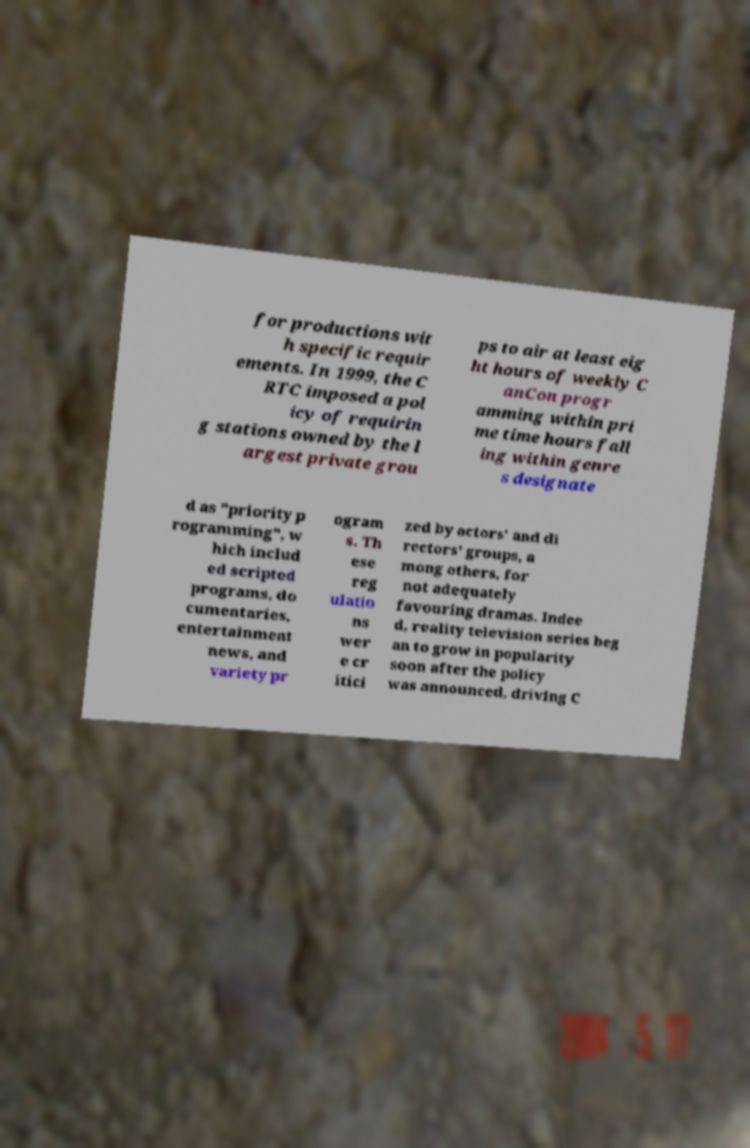There's text embedded in this image that I need extracted. Can you transcribe it verbatim? for productions wit h specific requir ements. In 1999, the C RTC imposed a pol icy of requirin g stations owned by the l argest private grou ps to air at least eig ht hours of weekly C anCon progr amming within pri me time hours fall ing within genre s designate d as "priority p rogramming", w hich includ ed scripted programs, do cumentaries, entertainment news, and variety pr ogram s. Th ese reg ulatio ns wer e cr itici zed by actors' and di rectors' groups, a mong others, for not adequately favouring dramas. Indee d, reality television series beg an to grow in popularity soon after the policy was announced, driving C 